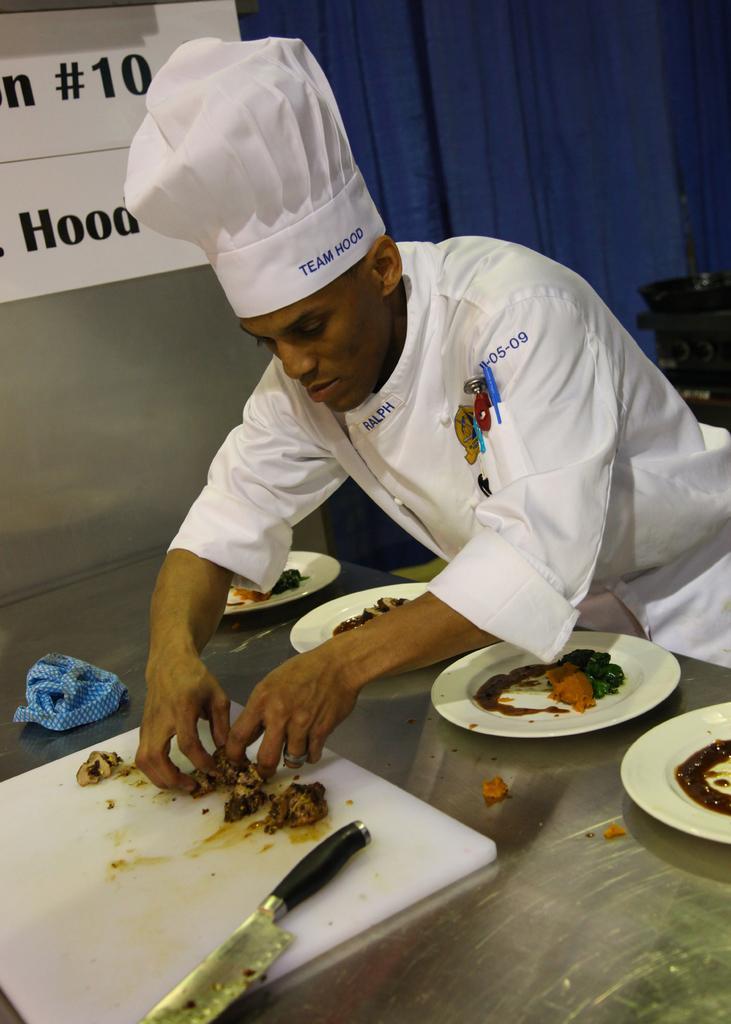Can you describe this image briefly? In this picture there is a man standing and holding the food. There is food on the chopping and there is a knife on the chopping board. There is food on the plates and there are plates on the table. At the back there is a chair and there is a blue curtain. There is a board on the wall and there is a text on the board. 